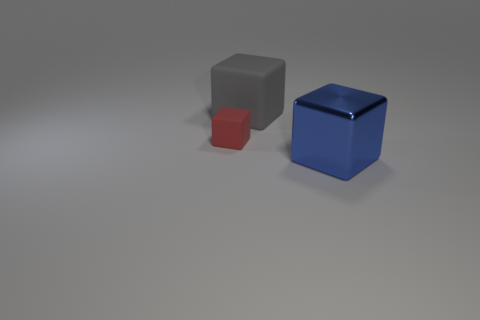Do the large gray rubber object and the small red thing have the same shape?
Give a very brief answer. Yes. There is a matte object on the left side of the big block that is left of the large object in front of the gray block; how big is it?
Ensure brevity in your answer.  Small. Are there any blocks to the left of the block behind the tiny object?
Provide a short and direct response. Yes. What number of objects are in front of the rubber object on the left side of the matte object that is on the right side of the red cube?
Offer a very short reply. 1. There is a object that is both in front of the gray matte cube and on the right side of the tiny red object; what color is it?
Give a very brief answer. Blue. What number of small objects are the same color as the big shiny block?
Keep it short and to the point. 0. How many blocks are either big gray matte things or large objects?
Your response must be concise. 2. There is another thing that is the same size as the blue object; what is its color?
Keep it short and to the point. Gray. Is there a tiny red matte thing on the left side of the cube that is on the right side of the matte thing that is on the right side of the small rubber object?
Offer a very short reply. Yes. The red rubber block has what size?
Offer a very short reply. Small. 